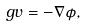<formula> <loc_0><loc_0><loc_500><loc_500>\ g v = - \nabla \phi ,</formula> 